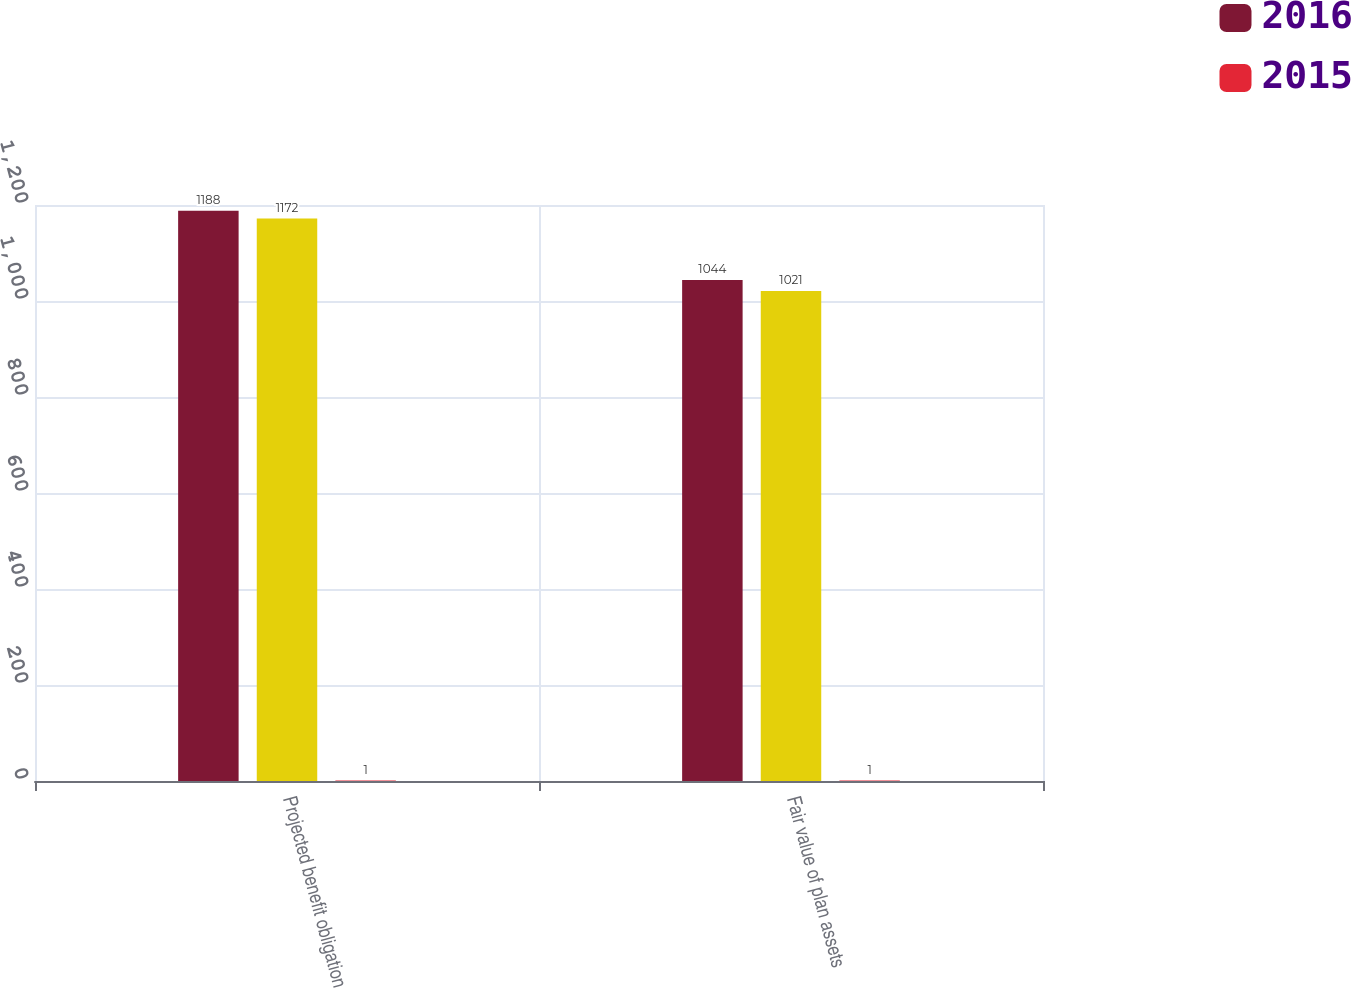<chart> <loc_0><loc_0><loc_500><loc_500><stacked_bar_chart><ecel><fcel>Projected benefit obligation<fcel>Fair value of plan assets<nl><fcel>2016<fcel>1188<fcel>1044<nl><fcel>nan<fcel>1172<fcel>1021<nl><fcel>2015<fcel>1<fcel>1<nl></chart> 